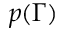<formula> <loc_0><loc_0><loc_500><loc_500>p ( \Gamma )</formula> 